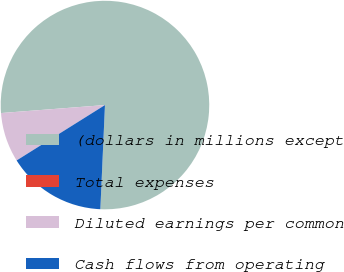Convert chart. <chart><loc_0><loc_0><loc_500><loc_500><pie_chart><fcel>(dollars in millions except<fcel>Total expenses<fcel>Diluted earnings per common<fcel>Cash flows from operating<nl><fcel>76.92%<fcel>0.0%<fcel>7.69%<fcel>15.38%<nl></chart> 